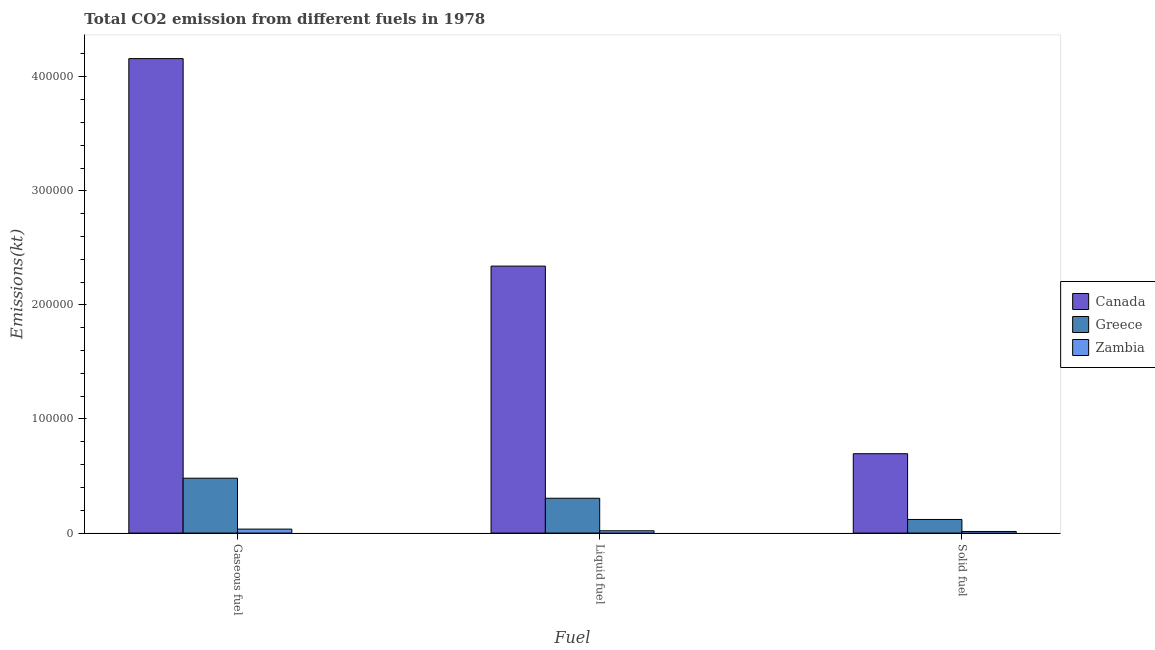How many different coloured bars are there?
Your answer should be compact. 3. How many bars are there on the 1st tick from the left?
Ensure brevity in your answer.  3. What is the label of the 3rd group of bars from the left?
Your answer should be compact. Solid fuel. What is the amount of co2 emissions from gaseous fuel in Zambia?
Offer a very short reply. 3476.32. Across all countries, what is the maximum amount of co2 emissions from liquid fuel?
Offer a terse response. 2.34e+05. Across all countries, what is the minimum amount of co2 emissions from solid fuel?
Your response must be concise. 1404.46. In which country was the amount of co2 emissions from liquid fuel maximum?
Give a very brief answer. Canada. In which country was the amount of co2 emissions from gaseous fuel minimum?
Provide a short and direct response. Zambia. What is the total amount of co2 emissions from liquid fuel in the graph?
Your response must be concise. 2.67e+05. What is the difference between the amount of co2 emissions from gaseous fuel in Greece and that in Canada?
Make the answer very short. -3.68e+05. What is the difference between the amount of co2 emissions from liquid fuel in Greece and the amount of co2 emissions from solid fuel in Canada?
Ensure brevity in your answer.  -3.90e+04. What is the average amount of co2 emissions from gaseous fuel per country?
Ensure brevity in your answer.  1.56e+05. What is the difference between the amount of co2 emissions from gaseous fuel and amount of co2 emissions from liquid fuel in Canada?
Ensure brevity in your answer.  1.82e+05. What is the ratio of the amount of co2 emissions from liquid fuel in Canada to that in Greece?
Your response must be concise. 7.67. Is the amount of co2 emissions from liquid fuel in Zambia less than that in Greece?
Give a very brief answer. Yes. Is the difference between the amount of co2 emissions from gaseous fuel in Zambia and Greece greater than the difference between the amount of co2 emissions from solid fuel in Zambia and Greece?
Provide a short and direct response. No. What is the difference between the highest and the second highest amount of co2 emissions from gaseous fuel?
Offer a very short reply. 3.68e+05. What is the difference between the highest and the lowest amount of co2 emissions from gaseous fuel?
Offer a very short reply. 4.12e+05. In how many countries, is the amount of co2 emissions from liquid fuel greater than the average amount of co2 emissions from liquid fuel taken over all countries?
Ensure brevity in your answer.  1. Is the sum of the amount of co2 emissions from gaseous fuel in Greece and Canada greater than the maximum amount of co2 emissions from solid fuel across all countries?
Offer a terse response. Yes. What does the 3rd bar from the right in Liquid fuel represents?
Provide a short and direct response. Canada. How many bars are there?
Provide a short and direct response. 9. Are all the bars in the graph horizontal?
Make the answer very short. No. Are the values on the major ticks of Y-axis written in scientific E-notation?
Your response must be concise. No. Does the graph contain any zero values?
Your response must be concise. No. Where does the legend appear in the graph?
Your answer should be very brief. Center right. How many legend labels are there?
Ensure brevity in your answer.  3. How are the legend labels stacked?
Give a very brief answer. Vertical. What is the title of the graph?
Keep it short and to the point. Total CO2 emission from different fuels in 1978. Does "Mali" appear as one of the legend labels in the graph?
Your answer should be compact. No. What is the label or title of the X-axis?
Your answer should be very brief. Fuel. What is the label or title of the Y-axis?
Ensure brevity in your answer.  Emissions(kt). What is the Emissions(kt) in Canada in Gaseous fuel?
Provide a succinct answer. 4.16e+05. What is the Emissions(kt) of Greece in Gaseous fuel?
Make the answer very short. 4.81e+04. What is the Emissions(kt) in Zambia in Gaseous fuel?
Your response must be concise. 3476.32. What is the Emissions(kt) in Canada in Liquid fuel?
Offer a terse response. 2.34e+05. What is the Emissions(kt) in Greece in Liquid fuel?
Keep it short and to the point. 3.05e+04. What is the Emissions(kt) of Zambia in Liquid fuel?
Give a very brief answer. 2009.52. What is the Emissions(kt) in Canada in Solid fuel?
Your answer should be compact. 6.96e+04. What is the Emissions(kt) in Greece in Solid fuel?
Provide a short and direct response. 1.19e+04. What is the Emissions(kt) of Zambia in Solid fuel?
Keep it short and to the point. 1404.46. Across all Fuel, what is the maximum Emissions(kt) of Canada?
Offer a very short reply. 4.16e+05. Across all Fuel, what is the maximum Emissions(kt) of Greece?
Ensure brevity in your answer.  4.81e+04. Across all Fuel, what is the maximum Emissions(kt) of Zambia?
Make the answer very short. 3476.32. Across all Fuel, what is the minimum Emissions(kt) of Canada?
Keep it short and to the point. 6.96e+04. Across all Fuel, what is the minimum Emissions(kt) in Greece?
Offer a terse response. 1.19e+04. Across all Fuel, what is the minimum Emissions(kt) of Zambia?
Give a very brief answer. 1404.46. What is the total Emissions(kt) in Canada in the graph?
Keep it short and to the point. 7.19e+05. What is the total Emissions(kt) of Greece in the graph?
Provide a short and direct response. 9.05e+04. What is the total Emissions(kt) of Zambia in the graph?
Keep it short and to the point. 6890.29. What is the difference between the Emissions(kt) of Canada in Gaseous fuel and that in Liquid fuel?
Offer a terse response. 1.82e+05. What is the difference between the Emissions(kt) of Greece in Gaseous fuel and that in Liquid fuel?
Offer a very short reply. 1.76e+04. What is the difference between the Emissions(kt) in Zambia in Gaseous fuel and that in Liquid fuel?
Keep it short and to the point. 1466.8. What is the difference between the Emissions(kt) of Canada in Gaseous fuel and that in Solid fuel?
Your answer should be compact. 3.46e+05. What is the difference between the Emissions(kt) in Greece in Gaseous fuel and that in Solid fuel?
Keep it short and to the point. 3.61e+04. What is the difference between the Emissions(kt) of Zambia in Gaseous fuel and that in Solid fuel?
Your answer should be very brief. 2071.86. What is the difference between the Emissions(kt) in Canada in Liquid fuel and that in Solid fuel?
Make the answer very short. 1.64e+05. What is the difference between the Emissions(kt) of Greece in Liquid fuel and that in Solid fuel?
Ensure brevity in your answer.  1.86e+04. What is the difference between the Emissions(kt) in Zambia in Liquid fuel and that in Solid fuel?
Make the answer very short. 605.05. What is the difference between the Emissions(kt) of Canada in Gaseous fuel and the Emissions(kt) of Greece in Liquid fuel?
Give a very brief answer. 3.85e+05. What is the difference between the Emissions(kt) of Canada in Gaseous fuel and the Emissions(kt) of Zambia in Liquid fuel?
Provide a succinct answer. 4.14e+05. What is the difference between the Emissions(kt) in Greece in Gaseous fuel and the Emissions(kt) in Zambia in Liquid fuel?
Offer a very short reply. 4.61e+04. What is the difference between the Emissions(kt) in Canada in Gaseous fuel and the Emissions(kt) in Greece in Solid fuel?
Your answer should be compact. 4.04e+05. What is the difference between the Emissions(kt) in Canada in Gaseous fuel and the Emissions(kt) in Zambia in Solid fuel?
Offer a very short reply. 4.14e+05. What is the difference between the Emissions(kt) of Greece in Gaseous fuel and the Emissions(kt) of Zambia in Solid fuel?
Provide a short and direct response. 4.67e+04. What is the difference between the Emissions(kt) in Canada in Liquid fuel and the Emissions(kt) in Greece in Solid fuel?
Offer a terse response. 2.22e+05. What is the difference between the Emissions(kt) of Canada in Liquid fuel and the Emissions(kt) of Zambia in Solid fuel?
Your response must be concise. 2.33e+05. What is the difference between the Emissions(kt) of Greece in Liquid fuel and the Emissions(kt) of Zambia in Solid fuel?
Your answer should be very brief. 2.91e+04. What is the average Emissions(kt) of Canada per Fuel?
Your response must be concise. 2.40e+05. What is the average Emissions(kt) of Greece per Fuel?
Your answer should be compact. 3.02e+04. What is the average Emissions(kt) of Zambia per Fuel?
Make the answer very short. 2296.76. What is the difference between the Emissions(kt) of Canada and Emissions(kt) of Greece in Gaseous fuel?
Your answer should be very brief. 3.68e+05. What is the difference between the Emissions(kt) of Canada and Emissions(kt) of Zambia in Gaseous fuel?
Offer a terse response. 4.12e+05. What is the difference between the Emissions(kt) of Greece and Emissions(kt) of Zambia in Gaseous fuel?
Keep it short and to the point. 4.46e+04. What is the difference between the Emissions(kt) of Canada and Emissions(kt) of Greece in Liquid fuel?
Provide a short and direct response. 2.03e+05. What is the difference between the Emissions(kt) of Canada and Emissions(kt) of Zambia in Liquid fuel?
Your answer should be compact. 2.32e+05. What is the difference between the Emissions(kt) in Greece and Emissions(kt) in Zambia in Liquid fuel?
Provide a short and direct response. 2.85e+04. What is the difference between the Emissions(kt) of Canada and Emissions(kt) of Greece in Solid fuel?
Your answer should be very brief. 5.76e+04. What is the difference between the Emissions(kt) of Canada and Emissions(kt) of Zambia in Solid fuel?
Keep it short and to the point. 6.82e+04. What is the difference between the Emissions(kt) in Greece and Emissions(kt) in Zambia in Solid fuel?
Your response must be concise. 1.05e+04. What is the ratio of the Emissions(kt) in Canada in Gaseous fuel to that in Liquid fuel?
Provide a succinct answer. 1.78. What is the ratio of the Emissions(kt) in Greece in Gaseous fuel to that in Liquid fuel?
Your answer should be compact. 1.58. What is the ratio of the Emissions(kt) in Zambia in Gaseous fuel to that in Liquid fuel?
Keep it short and to the point. 1.73. What is the ratio of the Emissions(kt) in Canada in Gaseous fuel to that in Solid fuel?
Offer a very short reply. 5.98. What is the ratio of the Emissions(kt) of Greece in Gaseous fuel to that in Solid fuel?
Give a very brief answer. 4.03. What is the ratio of the Emissions(kt) in Zambia in Gaseous fuel to that in Solid fuel?
Your answer should be very brief. 2.48. What is the ratio of the Emissions(kt) in Canada in Liquid fuel to that in Solid fuel?
Your answer should be compact. 3.36. What is the ratio of the Emissions(kt) of Greece in Liquid fuel to that in Solid fuel?
Provide a short and direct response. 2.56. What is the ratio of the Emissions(kt) of Zambia in Liquid fuel to that in Solid fuel?
Make the answer very short. 1.43. What is the difference between the highest and the second highest Emissions(kt) of Canada?
Provide a succinct answer. 1.82e+05. What is the difference between the highest and the second highest Emissions(kt) in Greece?
Offer a very short reply. 1.76e+04. What is the difference between the highest and the second highest Emissions(kt) in Zambia?
Give a very brief answer. 1466.8. What is the difference between the highest and the lowest Emissions(kt) of Canada?
Keep it short and to the point. 3.46e+05. What is the difference between the highest and the lowest Emissions(kt) in Greece?
Your response must be concise. 3.61e+04. What is the difference between the highest and the lowest Emissions(kt) in Zambia?
Keep it short and to the point. 2071.86. 